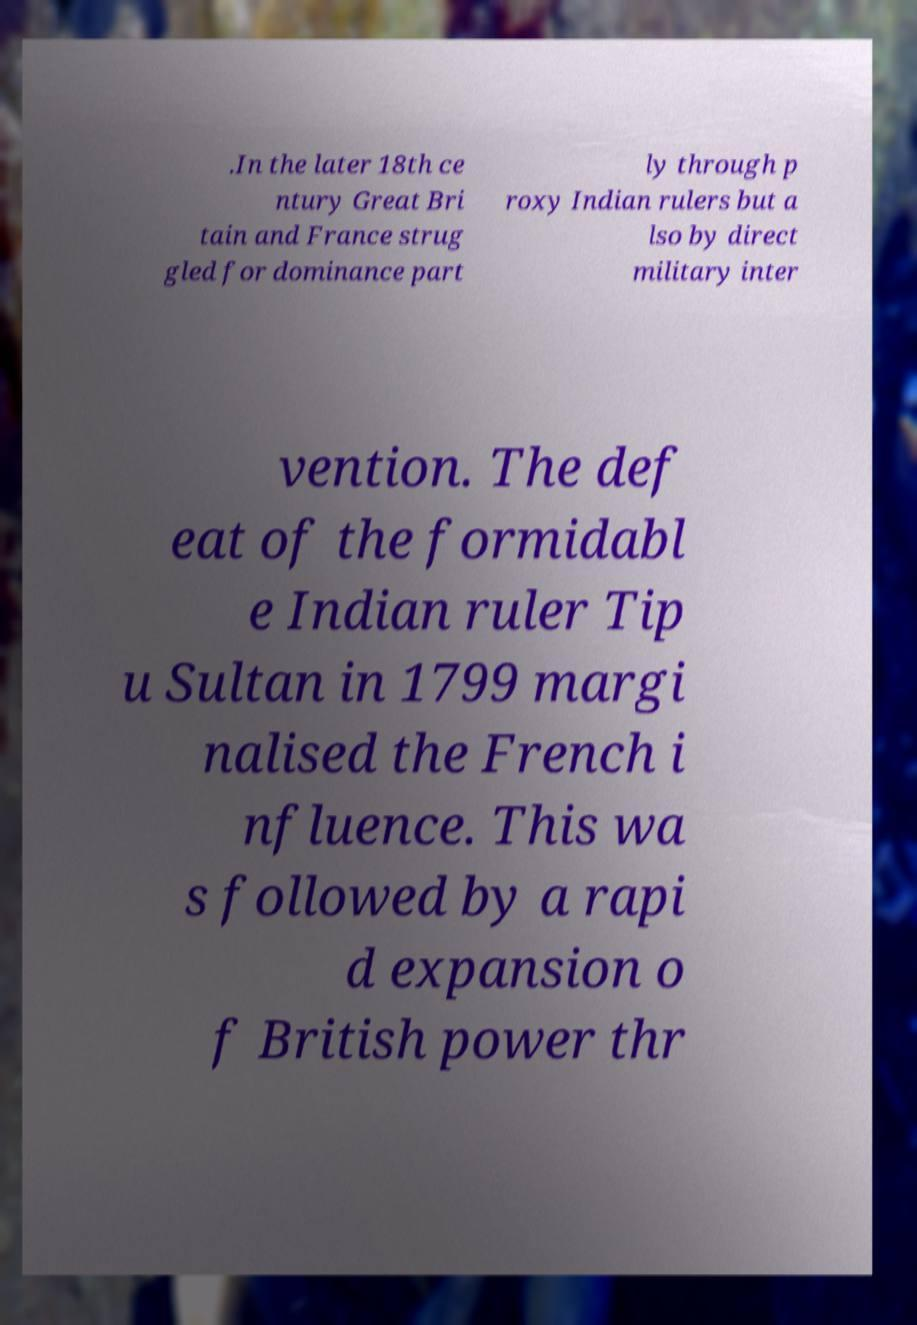Could you assist in decoding the text presented in this image and type it out clearly? .In the later 18th ce ntury Great Bri tain and France strug gled for dominance part ly through p roxy Indian rulers but a lso by direct military inter vention. The def eat of the formidabl e Indian ruler Tip u Sultan in 1799 margi nalised the French i nfluence. This wa s followed by a rapi d expansion o f British power thr 